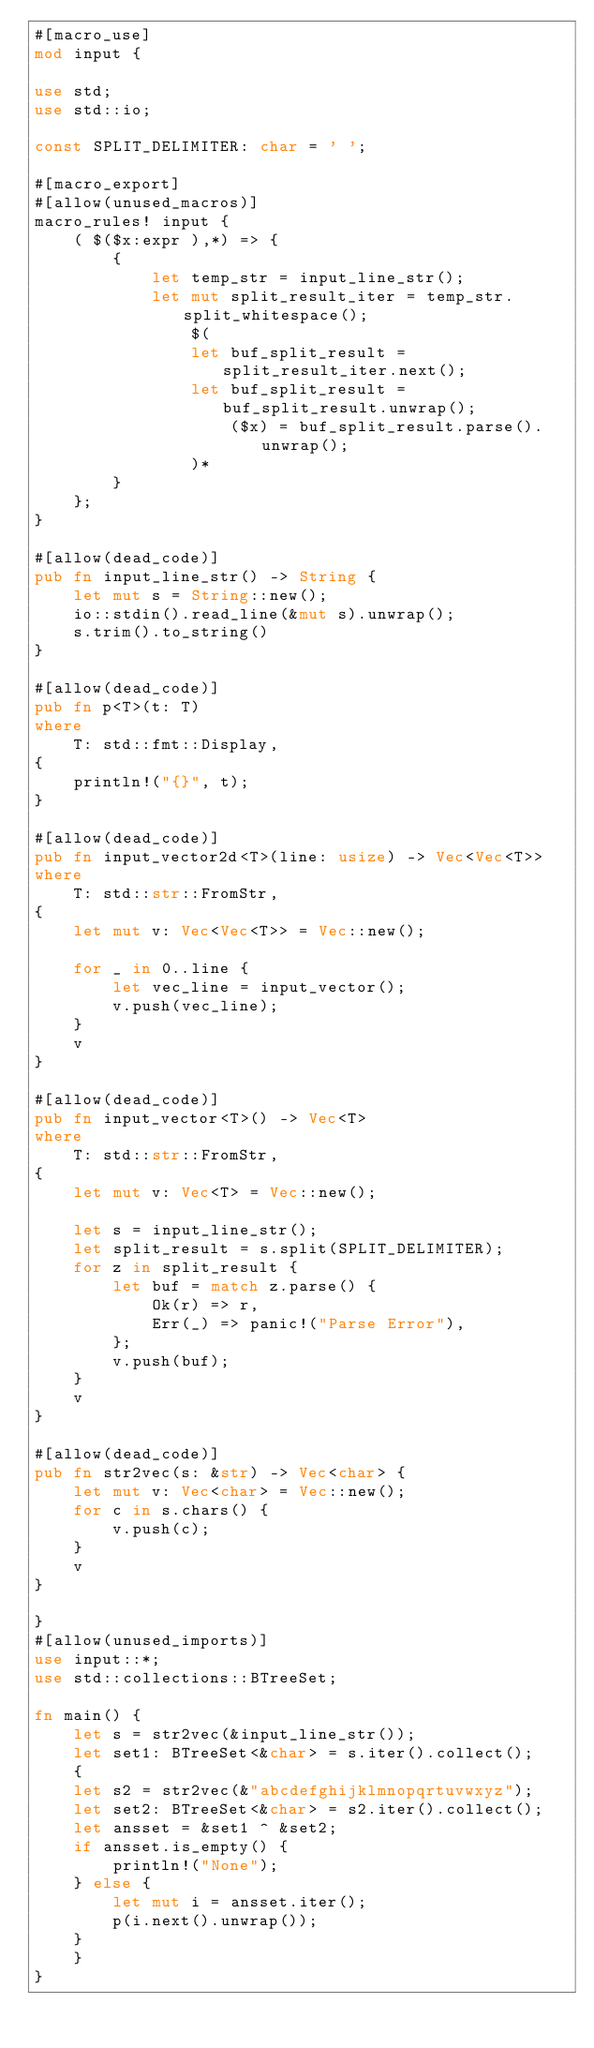<code> <loc_0><loc_0><loc_500><loc_500><_Rust_>#[macro_use]
mod input {

use std;
use std::io;

const SPLIT_DELIMITER: char = ' ';

#[macro_export]
#[allow(unused_macros)]
macro_rules! input {
    ( $($x:expr ),*) => {
        {
            let temp_str = input_line_str();
            let mut split_result_iter = temp_str.split_whitespace();
                $(
                let buf_split_result = split_result_iter.next();
                let buf_split_result = buf_split_result.unwrap();
                    ($x) = buf_split_result.parse().unwrap();
                )*
        }
    };
}

#[allow(dead_code)]
pub fn input_line_str() -> String {
    let mut s = String::new();
    io::stdin().read_line(&mut s).unwrap();
    s.trim().to_string()
}

#[allow(dead_code)]
pub fn p<T>(t: T)
where
    T: std::fmt::Display,
{
    println!("{}", t);
}

#[allow(dead_code)]
pub fn input_vector2d<T>(line: usize) -> Vec<Vec<T>>
where
    T: std::str::FromStr,
{
    let mut v: Vec<Vec<T>> = Vec::new();

    for _ in 0..line {
        let vec_line = input_vector();
        v.push(vec_line);
    }
    v
}

#[allow(dead_code)]
pub fn input_vector<T>() -> Vec<T>
where
    T: std::str::FromStr,
{
    let mut v: Vec<T> = Vec::new();

    let s = input_line_str();
    let split_result = s.split(SPLIT_DELIMITER);
    for z in split_result {
        let buf = match z.parse() {
            Ok(r) => r,
            Err(_) => panic!("Parse Error"),
        };
        v.push(buf);
    }
    v
}

#[allow(dead_code)]
pub fn str2vec(s: &str) -> Vec<char> {
    let mut v: Vec<char> = Vec::new();
    for c in s.chars() {
        v.push(c);
    }
    v
}

}
#[allow(unused_imports)]
use input::*;
use std::collections::BTreeSet;

fn main() {
    let s = str2vec(&input_line_str());
    let set1: BTreeSet<&char> = s.iter().collect();
    {
    let s2 = str2vec(&"abcdefghijklmnopqrtuvwxyz");
    let set2: BTreeSet<&char> = s2.iter().collect();
    let ansset = &set1 ^ &set2;
    if ansset.is_empty() {
        println!("None");
    } else {
        let mut i = ansset.iter();
        p(i.next().unwrap());
    }
    }
}</code> 